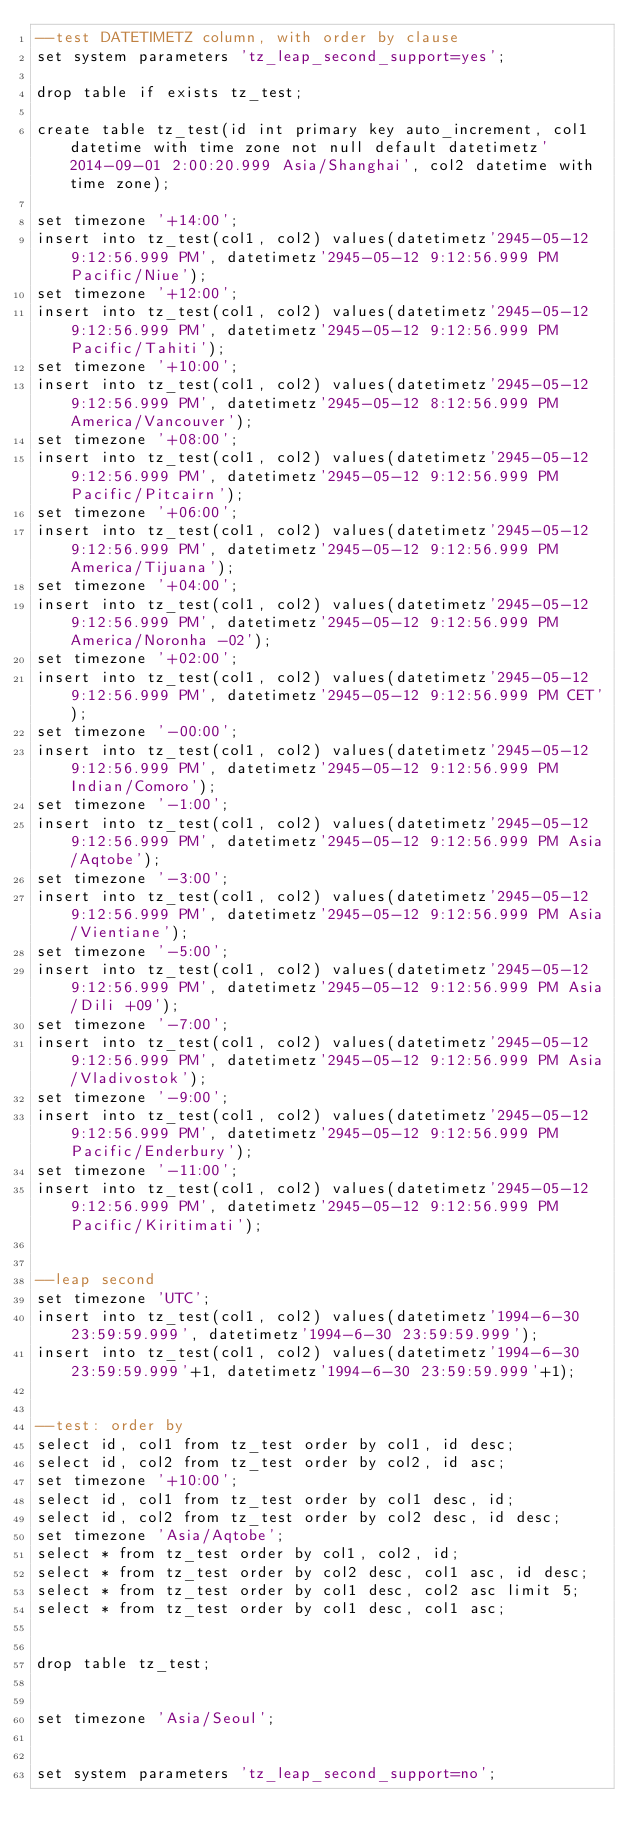<code> <loc_0><loc_0><loc_500><loc_500><_SQL_>--test DATETIMETZ column, with order by clause
set system parameters 'tz_leap_second_support=yes';

drop table if exists tz_test;

create table tz_test(id int primary key auto_increment, col1 datetime with time zone not null default datetimetz'2014-09-01 2:00:20.999 Asia/Shanghai', col2 datetime with time zone);

set timezone '+14:00';
insert into tz_test(col1, col2) values(datetimetz'2945-05-12 9:12:56.999 PM', datetimetz'2945-05-12 9:12:56.999 PM Pacific/Niue');
set timezone '+12:00';
insert into tz_test(col1, col2) values(datetimetz'2945-05-12 9:12:56.999 PM', datetimetz'2945-05-12 9:12:56.999 PM Pacific/Tahiti');
set timezone '+10:00';
insert into tz_test(col1, col2) values(datetimetz'2945-05-12 9:12:56.999 PM', datetimetz'2945-05-12 8:12:56.999 PM America/Vancouver');
set timezone '+08:00';
insert into tz_test(col1, col2) values(datetimetz'2945-05-12 9:12:56.999 PM', datetimetz'2945-05-12 9:12:56.999 PM Pacific/Pitcairn');
set timezone '+06:00';
insert into tz_test(col1, col2) values(datetimetz'2945-05-12 9:12:56.999 PM', datetimetz'2945-05-12 9:12:56.999 PM America/Tijuana');
set timezone '+04:00';
insert into tz_test(col1, col2) values(datetimetz'2945-05-12 9:12:56.999 PM', datetimetz'2945-05-12 9:12:56.999 PM America/Noronha -02');
set timezone '+02:00';
insert into tz_test(col1, col2) values(datetimetz'2945-05-12 9:12:56.999 PM', datetimetz'2945-05-12 9:12:56.999 PM CET');
set timezone '-00:00';
insert into tz_test(col1, col2) values(datetimetz'2945-05-12 9:12:56.999 PM', datetimetz'2945-05-12 9:12:56.999 PM Indian/Comoro');
set timezone '-1:00';
insert into tz_test(col1, col2) values(datetimetz'2945-05-12 9:12:56.999 PM', datetimetz'2945-05-12 9:12:56.999 PM Asia/Aqtobe');
set timezone '-3:00';
insert into tz_test(col1, col2) values(datetimetz'2945-05-12 9:12:56.999 PM', datetimetz'2945-05-12 9:12:56.999 PM Asia/Vientiane');
set timezone '-5:00';
insert into tz_test(col1, col2) values(datetimetz'2945-05-12 9:12:56.999 PM', datetimetz'2945-05-12 9:12:56.999 PM Asia/Dili +09');
set timezone '-7:00';
insert into tz_test(col1, col2) values(datetimetz'2945-05-12 9:12:56.999 PM', datetimetz'2945-05-12 9:12:56.999 PM Asia/Vladivostok');
set timezone '-9:00';
insert into tz_test(col1, col2) values(datetimetz'2945-05-12 9:12:56.999 PM', datetimetz'2945-05-12 9:12:56.999 PM Pacific/Enderbury');
set timezone '-11:00';
insert into tz_test(col1, col2) values(datetimetz'2945-05-12 9:12:56.999 PM', datetimetz'2945-05-12 9:12:56.999 PM Pacific/Kiritimati');


--leap second
set timezone 'UTC';
insert into tz_test(col1, col2) values(datetimetz'1994-6-30 23:59:59.999', datetimetz'1994-6-30 23:59:59.999');
insert into tz_test(col1, col2) values(datetimetz'1994-6-30 23:59:59.999'+1, datetimetz'1994-6-30 23:59:59.999'+1);


--test: order by
select id, col1 from tz_test order by col1, id desc;
select id, col2 from tz_test order by col2, id asc;
set timezone '+10:00';
select id, col1 from tz_test order by col1 desc, id;
select id, col2 from tz_test order by col2 desc, id desc;
set timezone 'Asia/Aqtobe';
select * from tz_test order by col1, col2, id;
select * from tz_test order by col2 desc, col1 asc, id desc;
select * from tz_test order by col1 desc, col2 asc limit 5;
select * from tz_test order by col1 desc, col1 asc;


drop table tz_test;


set timezone 'Asia/Seoul';

 
set system parameters 'tz_leap_second_support=no';
</code> 